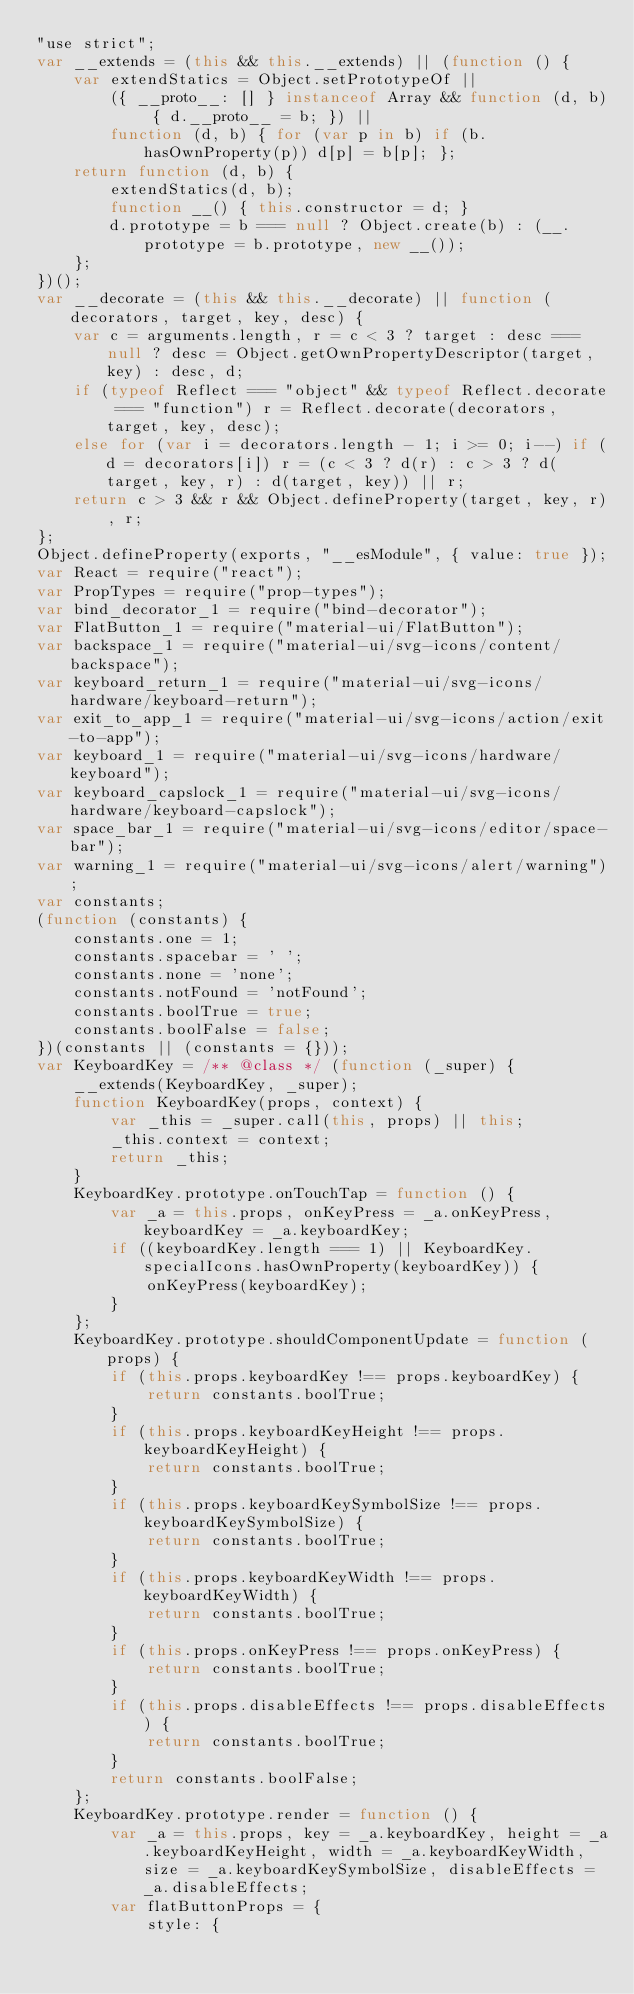Convert code to text. <code><loc_0><loc_0><loc_500><loc_500><_JavaScript_>"use strict";
var __extends = (this && this.__extends) || (function () {
    var extendStatics = Object.setPrototypeOf ||
        ({ __proto__: [] } instanceof Array && function (d, b) { d.__proto__ = b; }) ||
        function (d, b) { for (var p in b) if (b.hasOwnProperty(p)) d[p] = b[p]; };
    return function (d, b) {
        extendStatics(d, b);
        function __() { this.constructor = d; }
        d.prototype = b === null ? Object.create(b) : (__.prototype = b.prototype, new __());
    };
})();
var __decorate = (this && this.__decorate) || function (decorators, target, key, desc) {
    var c = arguments.length, r = c < 3 ? target : desc === null ? desc = Object.getOwnPropertyDescriptor(target, key) : desc, d;
    if (typeof Reflect === "object" && typeof Reflect.decorate === "function") r = Reflect.decorate(decorators, target, key, desc);
    else for (var i = decorators.length - 1; i >= 0; i--) if (d = decorators[i]) r = (c < 3 ? d(r) : c > 3 ? d(target, key, r) : d(target, key)) || r;
    return c > 3 && r && Object.defineProperty(target, key, r), r;
};
Object.defineProperty(exports, "__esModule", { value: true });
var React = require("react");
var PropTypes = require("prop-types");
var bind_decorator_1 = require("bind-decorator");
var FlatButton_1 = require("material-ui/FlatButton");
var backspace_1 = require("material-ui/svg-icons/content/backspace");
var keyboard_return_1 = require("material-ui/svg-icons/hardware/keyboard-return");
var exit_to_app_1 = require("material-ui/svg-icons/action/exit-to-app");
var keyboard_1 = require("material-ui/svg-icons/hardware/keyboard");
var keyboard_capslock_1 = require("material-ui/svg-icons/hardware/keyboard-capslock");
var space_bar_1 = require("material-ui/svg-icons/editor/space-bar");
var warning_1 = require("material-ui/svg-icons/alert/warning");
var constants;
(function (constants) {
    constants.one = 1;
    constants.spacebar = ' ';
    constants.none = 'none';
    constants.notFound = 'notFound';
    constants.boolTrue = true;
    constants.boolFalse = false;
})(constants || (constants = {}));
var KeyboardKey = /** @class */ (function (_super) {
    __extends(KeyboardKey, _super);
    function KeyboardKey(props, context) {
        var _this = _super.call(this, props) || this;
        _this.context = context;
        return _this;
    }
    KeyboardKey.prototype.onTouchTap = function () {
        var _a = this.props, onKeyPress = _a.onKeyPress, keyboardKey = _a.keyboardKey;
        if ((keyboardKey.length === 1) || KeyboardKey.specialIcons.hasOwnProperty(keyboardKey)) {
            onKeyPress(keyboardKey);
        }
    };
    KeyboardKey.prototype.shouldComponentUpdate = function (props) {
        if (this.props.keyboardKey !== props.keyboardKey) {
            return constants.boolTrue;
        }
        if (this.props.keyboardKeyHeight !== props.keyboardKeyHeight) {
            return constants.boolTrue;
        }
        if (this.props.keyboardKeySymbolSize !== props.keyboardKeySymbolSize) {
            return constants.boolTrue;
        }
        if (this.props.keyboardKeyWidth !== props.keyboardKeyWidth) {
            return constants.boolTrue;
        }
        if (this.props.onKeyPress !== props.onKeyPress) {
            return constants.boolTrue;
        }
        if (this.props.disableEffects !== props.disableEffects) {
            return constants.boolTrue;
        }
        return constants.boolFalse;
    };
    KeyboardKey.prototype.render = function () {
        var _a = this.props, key = _a.keyboardKey, height = _a.keyboardKeyHeight, width = _a.keyboardKeyWidth, size = _a.keyboardKeySymbolSize, disableEffects = _a.disableEffects;
        var flatButtonProps = {
            style: {</code> 